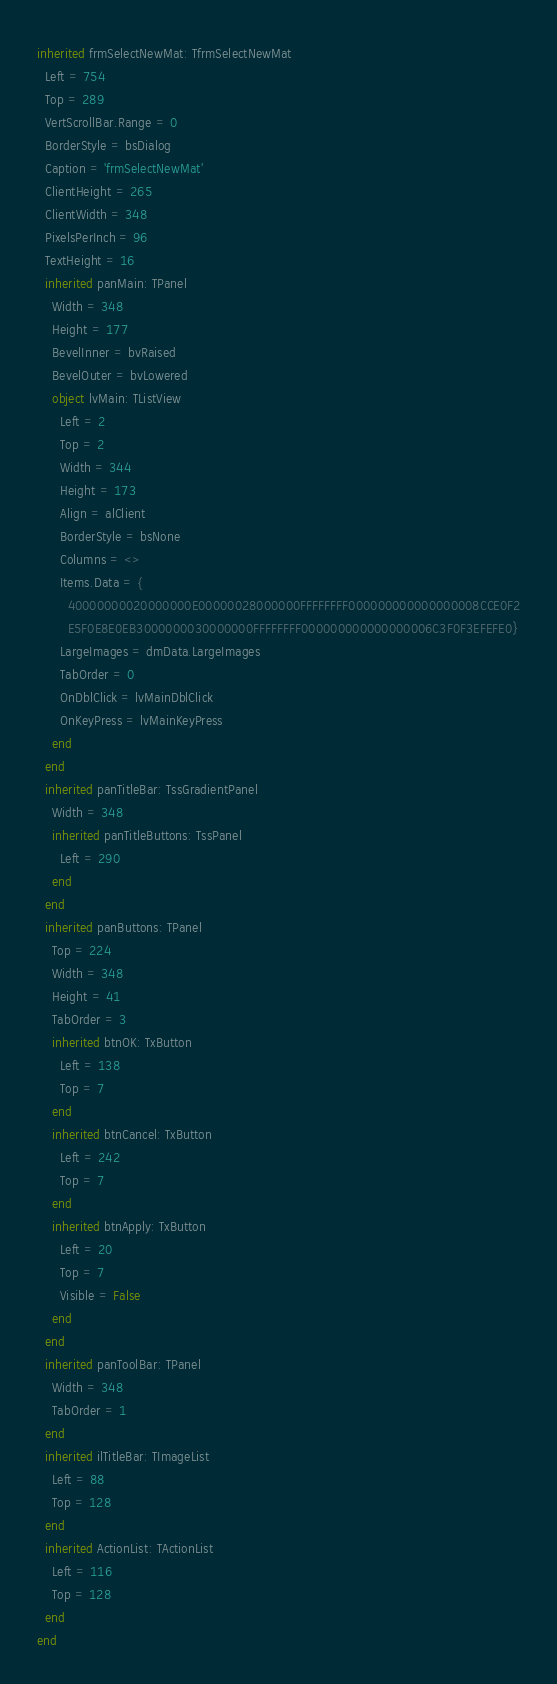<code> <loc_0><loc_0><loc_500><loc_500><_Pascal_>inherited frmSelectNewMat: TfrmSelectNewMat
  Left = 754
  Top = 289
  VertScrollBar.Range = 0
  BorderStyle = bsDialog
  Caption = 'frmSelectNewMat'
  ClientHeight = 265
  ClientWidth = 348
  PixelsPerInch = 96
  TextHeight = 16
  inherited panMain: TPanel
    Width = 348
    Height = 177
    BevelInner = bvRaised
    BevelOuter = bvLowered
    object lvMain: TListView
      Left = 2
      Top = 2
      Width = 344
      Height = 173
      Align = alClient
      BorderStyle = bsNone
      Columns = <>
      Items.Data = {
        40000000020000000E00000028000000FFFFFFFF000000000000000008CCE0F2
        E5F0E8E0EB3000000030000000FFFFFFFF000000000000000006C3F0F3EFEFE0}
      LargeImages = dmData.LargeImages
      TabOrder = 0
      OnDblClick = lvMainDblClick
      OnKeyPress = lvMainKeyPress
    end
  end
  inherited panTitleBar: TssGradientPanel
    Width = 348
    inherited panTitleButtons: TssPanel
      Left = 290
    end
  end
  inherited panButtons: TPanel
    Top = 224
    Width = 348
    Height = 41
    TabOrder = 3
    inherited btnOK: TxButton
      Left = 138
      Top = 7
    end
    inherited btnCancel: TxButton
      Left = 242
      Top = 7
    end
    inherited btnApply: TxButton
      Left = 20
      Top = 7
      Visible = False
    end
  end
  inherited panToolBar: TPanel
    Width = 348
    TabOrder = 1
  end
  inherited ilTitleBar: TImageList
    Left = 88
    Top = 128
  end
  inherited ActionList: TActionList
    Left = 116
    Top = 128
  end
end
</code> 